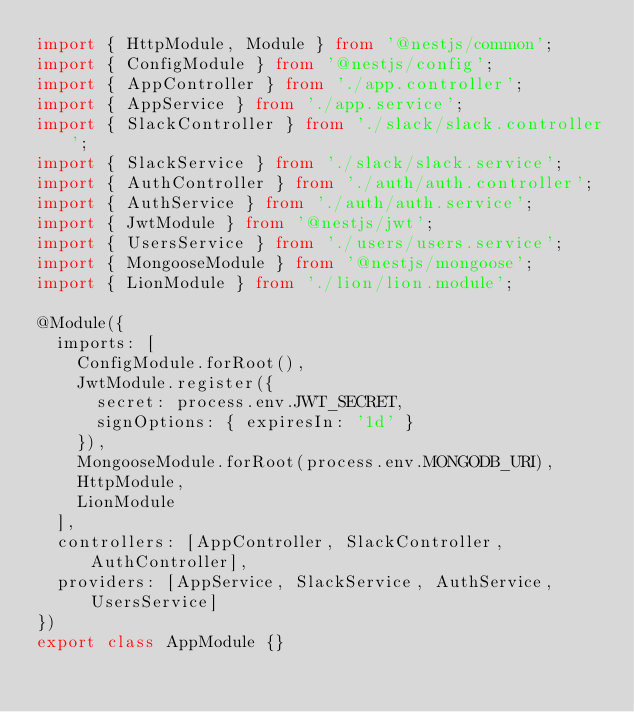<code> <loc_0><loc_0><loc_500><loc_500><_TypeScript_>import { HttpModule, Module } from '@nestjs/common';
import { ConfigModule } from '@nestjs/config';
import { AppController } from './app.controller';
import { AppService } from './app.service';
import { SlackController } from './slack/slack.controller';
import { SlackService } from './slack/slack.service';
import { AuthController } from './auth/auth.controller';
import { AuthService } from './auth/auth.service';
import { JwtModule } from '@nestjs/jwt';
import { UsersService } from './users/users.service';
import { MongooseModule } from '@nestjs/mongoose';
import { LionModule } from './lion/lion.module';

@Module({
  imports: [
    ConfigModule.forRoot(),
    JwtModule.register({
      secret: process.env.JWT_SECRET,
      signOptions: { expiresIn: '1d' }
    }),
    MongooseModule.forRoot(process.env.MONGODB_URI),
    HttpModule,
    LionModule
  ],
  controllers: [AppController, SlackController, AuthController],
  providers: [AppService, SlackService, AuthService, UsersService]
})
export class AppModule {}
</code> 